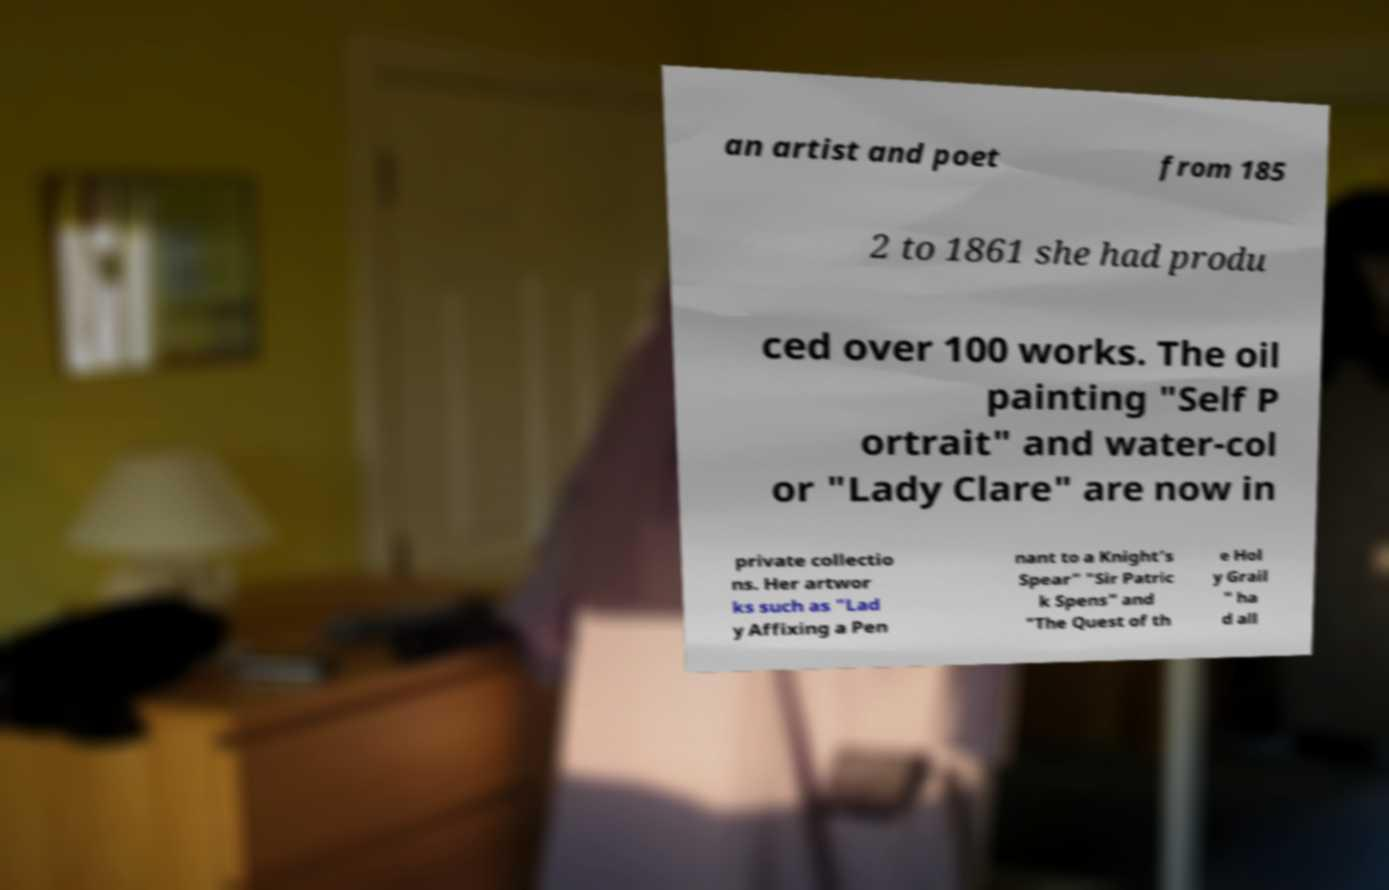Can you read and provide the text displayed in the image?This photo seems to have some interesting text. Can you extract and type it out for me? an artist and poet from 185 2 to 1861 she had produ ced over 100 works. The oil painting "Self P ortrait" and water-col or "Lady Clare" are now in private collectio ns. Her artwor ks such as "Lad y Affixing a Pen nant to a Knight’s Spear" "Sir Patric k Spens" and "The Quest of th e Hol y Grail " ha d all 